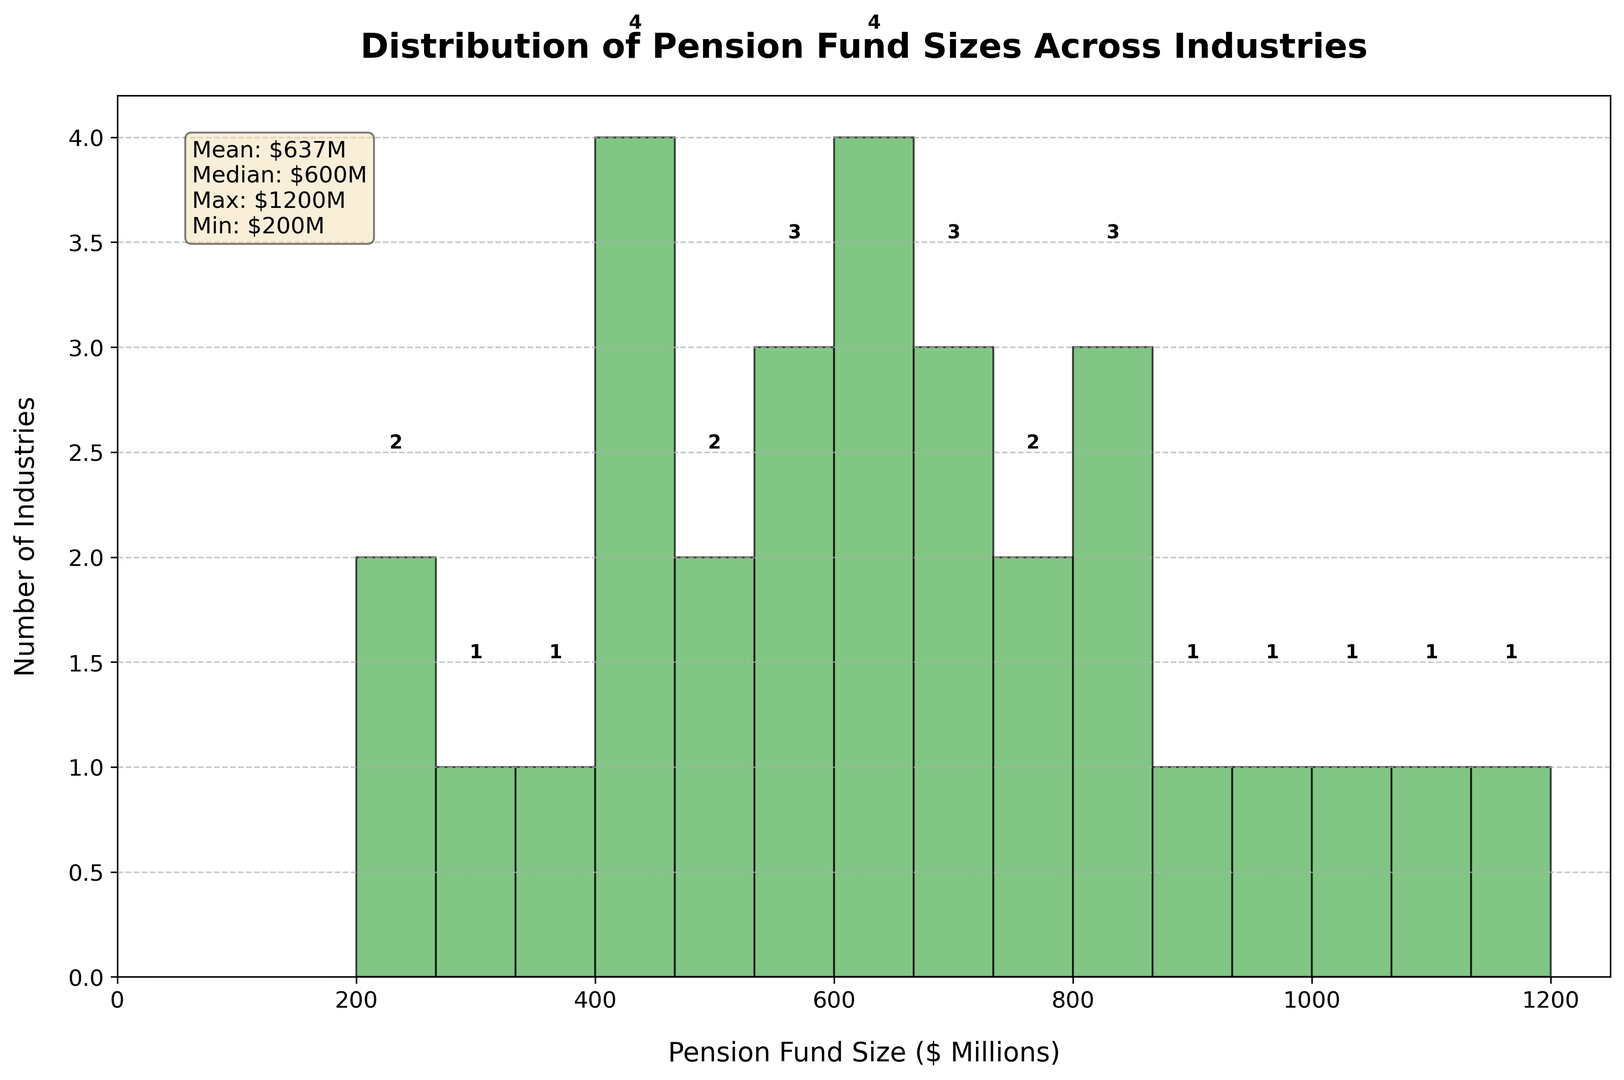Which industry has the largest average pension fund size? Identify the highest bar in the histogram and refer to the associated x-axis value. The industry with the largest average pension fund size is Finance.
Answer: Finance How many industries have an average pension fund size between $400 million and $800 million? Count the bars that fall within the x-axis range of 400 and 800 million. There are several bars in this range: from Retail to Aerospace.
Answer: 9 What is the average pension fund size across all industries? Refer to the text box in the figure with statistics. It mentions the mean value directly.
Answer: $673M Which industry has a smaller average pension fund size: Retail or Real Estate? Compare the positions of Retail and Real Estate on the x-axis. Retail has an average pension fund size of $400 million, while Real Estate has $550 million.
Answer: Retail What is the range of average pension fund sizes across industries? Identify the maximum and minimum values in the histogram. The highest value is $1200 million, and the lowest is $200 million. Subtract the minimum from the maximum. $1200M - $200M = $1000M
Answer: $1000M How many industries have an average pension fund size above $900 million? Count the bars that fall within the x-axis range greater than $900 million. These are Finance, Pharmaceuticals, and Insurance.
Answer: 3 What is the median average pension fund size? Refer to the text box in the figure with statistics. The median value is stated directly in the text box.
Answer: $650M Compare the number of industries with pension fund sizes below $500 million and those above $500 million. Count the bars on either side of the $500 million mark on the x-axis. There are 7 industries below $500 million and 17 industries above $500 million.
Answer: 7 below, 17 above How does the average pension fund size in Technology compare to that in Pharmaceuticals? Locate the bars for Technology and Pharmaceuticals, and compare their heights on the x-axis. Technology is $850 million, while Pharmaceuticals is $1100 million.
Answer: Technology is smaller 